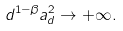Convert formula to latex. <formula><loc_0><loc_0><loc_500><loc_500>d ^ { 1 - \beta } a _ { d } ^ { 2 } \to + \infty .</formula> 